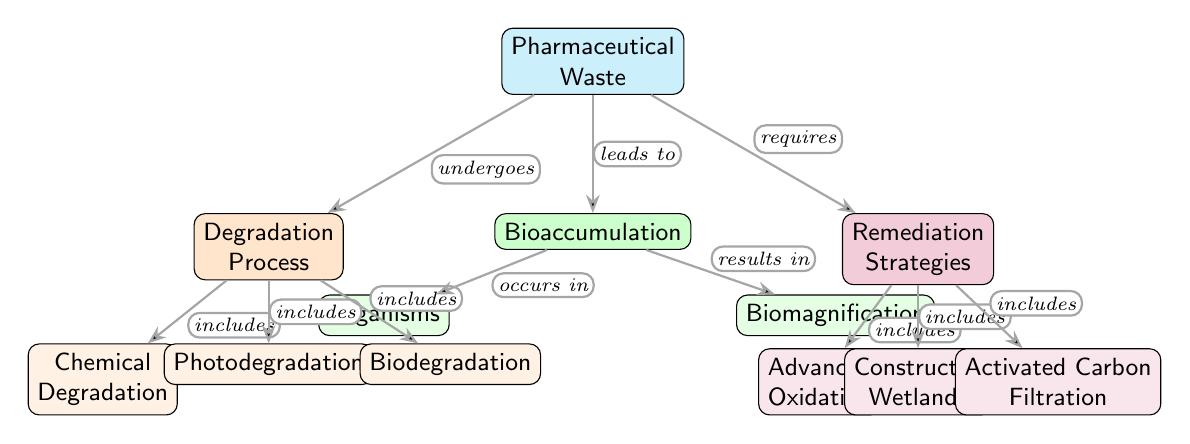What are the three main processes included in the Degradation Process? The diagram specifically lists three processes that fall under the "Degradation Process" node: Chemical Degradation, Photodegradation, and Biodegradation. These processes are visually connected to the "Degradation Process" node.
Answer: Chemical Degradation, Photodegradation, Biodegradation How many remediation strategies are shown in the diagram? In the diagram, the "Remediation Strategies" node connects to three sub-nodes: Advanced Oxidation, Constructed Wetlands, and Activated Carbon Filtration. This indicates there are three strategies illustrated.
Answer: 3 What does the Pharmaceutical Waste lead to? According to the diagram, one of the relationships indicated is that Pharmaceutical Waste "leads to" Bioaccumulation, which is visually represented as an edge connecting these two nodes.
Answer: Bioaccumulation Which degradation process is not a chemical process? Among the listed degradation processes, Photodegradation and Biodegradation are not solely chemical processes, while only Chemical Degradation is; thus, Photodegradation or Biodegradation can be identified as the correct responses to this query.
Answer: Photodegradation or Biodegradation In which category is Biomagnification found? The diagram shows that Biomagnification is a result of Bioaccumulation, which is visually connected as a sub-node under the Bioaccumulation node.
Answer: Bioaccumulation 